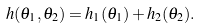<formula> <loc_0><loc_0><loc_500><loc_500>h ( \theta _ { 1 } , \theta _ { 2 } ) = h _ { 1 } ( \theta _ { 1 } ) + h _ { 2 } ( \theta _ { 2 } ) .</formula> 